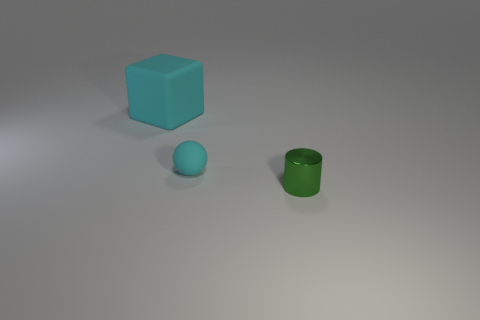There is a large object that is the same color as the ball; what is it made of?
Provide a succinct answer. Rubber. Is there any other thing that is the same size as the matte sphere?
Your response must be concise. Yes. How many objects are either cyan rubber things right of the large cyan rubber object or cyan rubber things on the right side of the block?
Your answer should be compact. 1. Is the size of the green cylinder the same as the cyan rubber cube?
Keep it short and to the point. No. Is the number of large cyan matte things greater than the number of small cyan matte cubes?
Your answer should be compact. Yes. How many other things are there of the same color as the big rubber block?
Make the answer very short. 1. How many things are green cylinders or big purple matte balls?
Keep it short and to the point. 1. What color is the matte thing that is behind the tiny object that is on the left side of the cylinder?
Your answer should be very brief. Cyan. Is the number of tiny matte things less than the number of large brown things?
Make the answer very short. No. Are there any big objects that have the same material as the tiny cyan sphere?
Provide a short and direct response. Yes. 